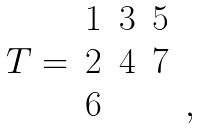<formula> <loc_0><loc_0><loc_500><loc_500>\begin{array} { c c c c c } & 1 & 3 & 5 & \\ T = & 2 & 4 & 7 & \\ & 6 & & & , \end{array}</formula> 